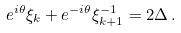Convert formula to latex. <formula><loc_0><loc_0><loc_500><loc_500>e ^ { i \theta } \xi _ { k } + e ^ { - i \theta } \xi _ { k + 1 } ^ { - 1 } = 2 \Delta \, .</formula> 